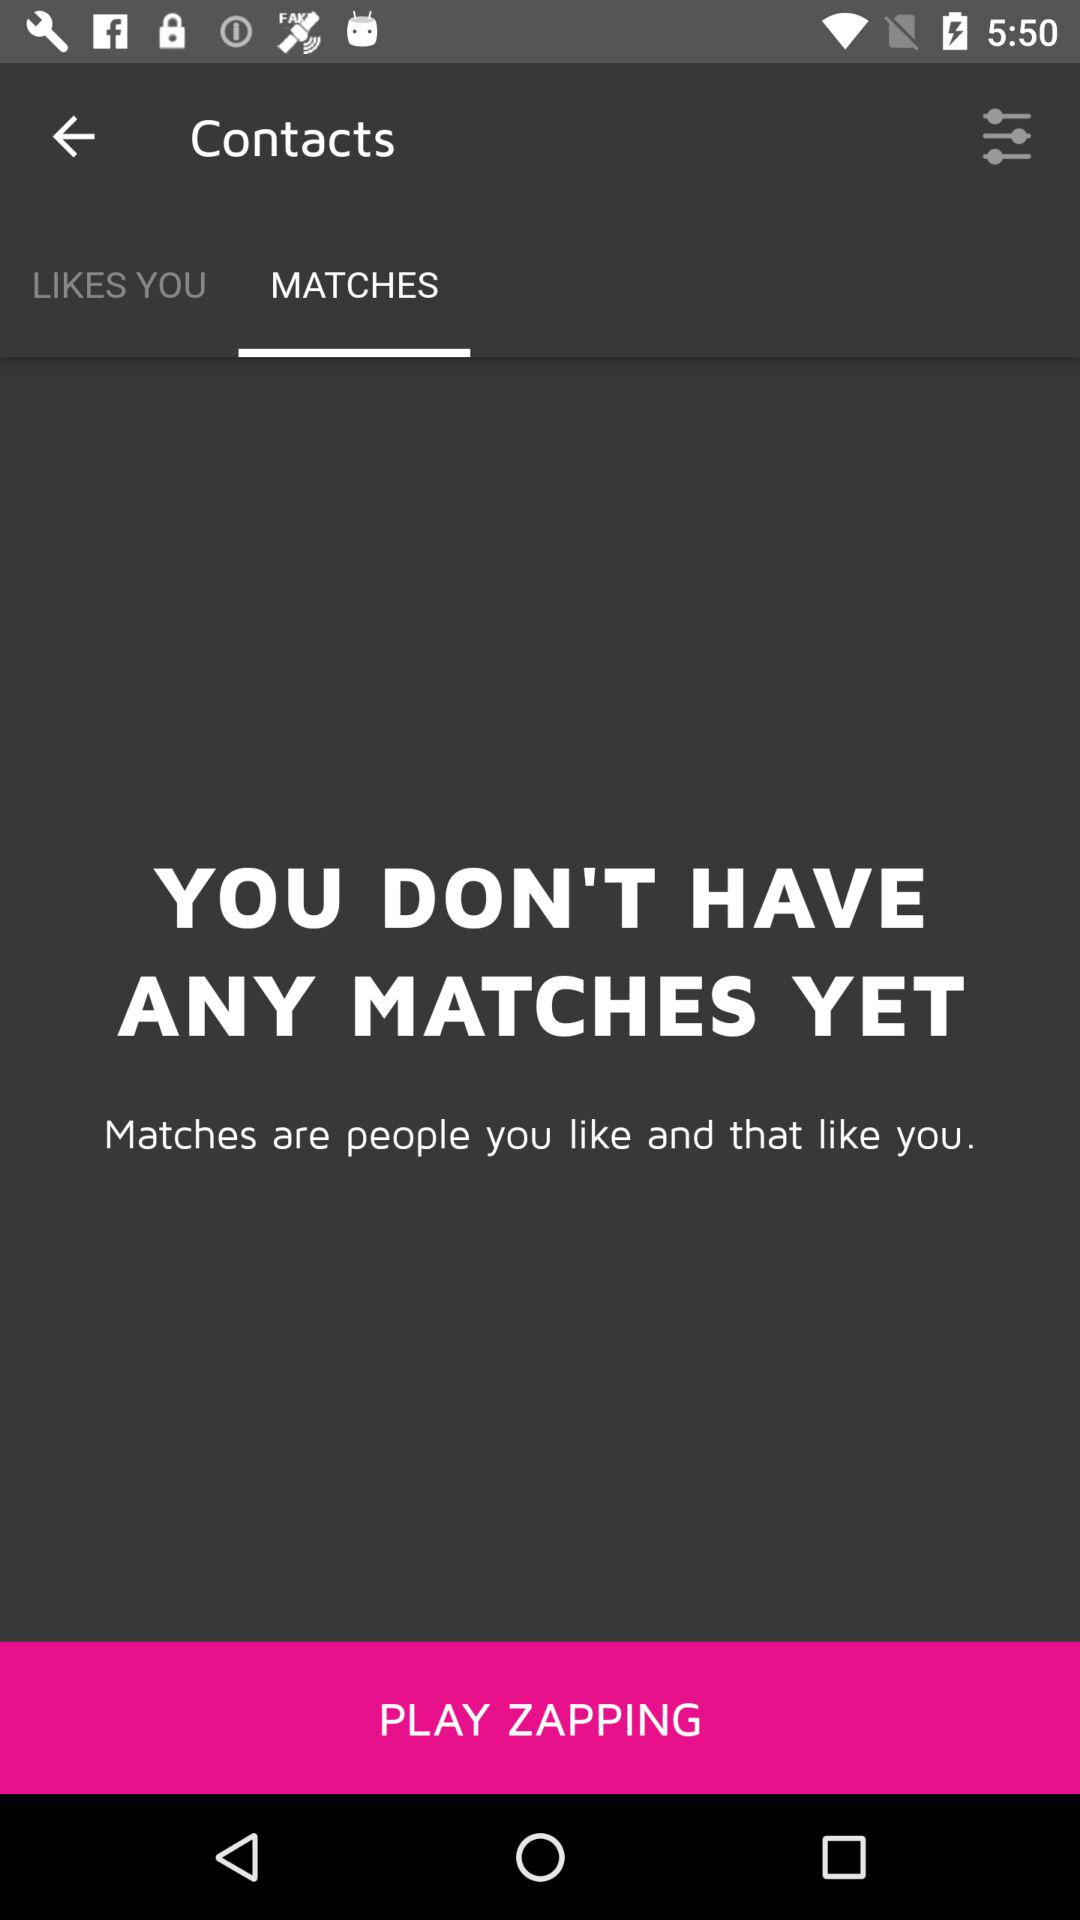Which tab is selected? The selected tab is "MATCHES". 